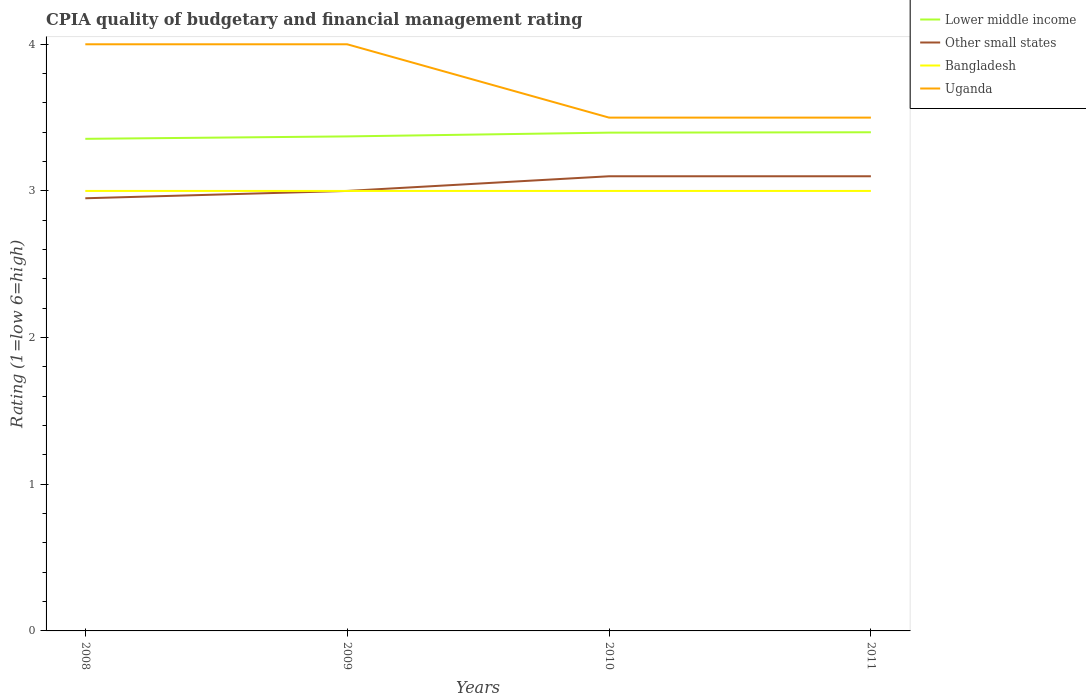How many different coloured lines are there?
Offer a very short reply. 4. Across all years, what is the maximum CPIA rating in Lower middle income?
Provide a succinct answer. 3.36. What is the total CPIA rating in Lower middle income in the graph?
Keep it short and to the point. -0.02. What is the difference between the highest and the second highest CPIA rating in Bangladesh?
Provide a succinct answer. 0. What is the difference between the highest and the lowest CPIA rating in Bangladesh?
Offer a terse response. 0. Is the CPIA rating in Bangladesh strictly greater than the CPIA rating in Lower middle income over the years?
Make the answer very short. Yes. How many years are there in the graph?
Offer a very short reply. 4. What is the difference between two consecutive major ticks on the Y-axis?
Keep it short and to the point. 1. Does the graph contain any zero values?
Give a very brief answer. No. How are the legend labels stacked?
Provide a short and direct response. Vertical. What is the title of the graph?
Provide a short and direct response. CPIA quality of budgetary and financial management rating. Does "Egypt, Arab Rep." appear as one of the legend labels in the graph?
Offer a very short reply. No. What is the label or title of the Y-axis?
Your answer should be very brief. Rating (1=low 6=high). What is the Rating (1=low 6=high) in Lower middle income in 2008?
Your answer should be very brief. 3.36. What is the Rating (1=low 6=high) of Other small states in 2008?
Your answer should be compact. 2.95. What is the Rating (1=low 6=high) in Uganda in 2008?
Ensure brevity in your answer.  4. What is the Rating (1=low 6=high) of Lower middle income in 2009?
Provide a short and direct response. 3.37. What is the Rating (1=low 6=high) in Bangladesh in 2009?
Your answer should be very brief. 3. What is the Rating (1=low 6=high) of Lower middle income in 2010?
Your answer should be compact. 3.4. What is the Rating (1=low 6=high) of Bangladesh in 2011?
Give a very brief answer. 3. Across all years, what is the maximum Rating (1=low 6=high) of Lower middle income?
Offer a terse response. 3.4. Across all years, what is the minimum Rating (1=low 6=high) in Lower middle income?
Provide a short and direct response. 3.36. Across all years, what is the minimum Rating (1=low 6=high) in Other small states?
Make the answer very short. 2.95. Across all years, what is the minimum Rating (1=low 6=high) in Bangladesh?
Your answer should be compact. 3. What is the total Rating (1=low 6=high) of Lower middle income in the graph?
Make the answer very short. 13.52. What is the total Rating (1=low 6=high) of Other small states in the graph?
Your answer should be compact. 12.15. What is the total Rating (1=low 6=high) of Bangladesh in the graph?
Your response must be concise. 12. What is the total Rating (1=low 6=high) of Uganda in the graph?
Keep it short and to the point. 15. What is the difference between the Rating (1=low 6=high) of Lower middle income in 2008 and that in 2009?
Provide a succinct answer. -0.02. What is the difference between the Rating (1=low 6=high) of Other small states in 2008 and that in 2009?
Your response must be concise. -0.05. What is the difference between the Rating (1=low 6=high) in Lower middle income in 2008 and that in 2010?
Provide a succinct answer. -0.04. What is the difference between the Rating (1=low 6=high) of Other small states in 2008 and that in 2010?
Your answer should be compact. -0.15. What is the difference between the Rating (1=low 6=high) of Lower middle income in 2008 and that in 2011?
Provide a short and direct response. -0.04. What is the difference between the Rating (1=low 6=high) in Other small states in 2008 and that in 2011?
Provide a short and direct response. -0.15. What is the difference between the Rating (1=low 6=high) in Bangladesh in 2008 and that in 2011?
Your response must be concise. 0. What is the difference between the Rating (1=low 6=high) in Lower middle income in 2009 and that in 2010?
Your answer should be compact. -0.03. What is the difference between the Rating (1=low 6=high) in Other small states in 2009 and that in 2010?
Provide a succinct answer. -0.1. What is the difference between the Rating (1=low 6=high) in Bangladesh in 2009 and that in 2010?
Keep it short and to the point. 0. What is the difference between the Rating (1=low 6=high) in Lower middle income in 2009 and that in 2011?
Give a very brief answer. -0.03. What is the difference between the Rating (1=low 6=high) in Bangladesh in 2009 and that in 2011?
Give a very brief answer. 0. What is the difference between the Rating (1=low 6=high) of Lower middle income in 2010 and that in 2011?
Your answer should be very brief. -0. What is the difference between the Rating (1=low 6=high) of Other small states in 2010 and that in 2011?
Offer a very short reply. 0. What is the difference between the Rating (1=low 6=high) of Bangladesh in 2010 and that in 2011?
Make the answer very short. 0. What is the difference between the Rating (1=low 6=high) of Lower middle income in 2008 and the Rating (1=low 6=high) of Other small states in 2009?
Provide a short and direct response. 0.36. What is the difference between the Rating (1=low 6=high) in Lower middle income in 2008 and the Rating (1=low 6=high) in Bangladesh in 2009?
Give a very brief answer. 0.36. What is the difference between the Rating (1=low 6=high) of Lower middle income in 2008 and the Rating (1=low 6=high) of Uganda in 2009?
Make the answer very short. -0.64. What is the difference between the Rating (1=low 6=high) of Other small states in 2008 and the Rating (1=low 6=high) of Uganda in 2009?
Your answer should be compact. -1.05. What is the difference between the Rating (1=low 6=high) of Bangladesh in 2008 and the Rating (1=low 6=high) of Uganda in 2009?
Offer a terse response. -1. What is the difference between the Rating (1=low 6=high) of Lower middle income in 2008 and the Rating (1=low 6=high) of Other small states in 2010?
Offer a very short reply. 0.26. What is the difference between the Rating (1=low 6=high) in Lower middle income in 2008 and the Rating (1=low 6=high) in Bangladesh in 2010?
Give a very brief answer. 0.36. What is the difference between the Rating (1=low 6=high) of Lower middle income in 2008 and the Rating (1=low 6=high) of Uganda in 2010?
Keep it short and to the point. -0.14. What is the difference between the Rating (1=low 6=high) of Other small states in 2008 and the Rating (1=low 6=high) of Bangladesh in 2010?
Give a very brief answer. -0.05. What is the difference between the Rating (1=low 6=high) of Other small states in 2008 and the Rating (1=low 6=high) of Uganda in 2010?
Offer a terse response. -0.55. What is the difference between the Rating (1=low 6=high) of Bangladesh in 2008 and the Rating (1=low 6=high) of Uganda in 2010?
Give a very brief answer. -0.5. What is the difference between the Rating (1=low 6=high) in Lower middle income in 2008 and the Rating (1=low 6=high) in Other small states in 2011?
Keep it short and to the point. 0.26. What is the difference between the Rating (1=low 6=high) of Lower middle income in 2008 and the Rating (1=low 6=high) of Bangladesh in 2011?
Your answer should be compact. 0.36. What is the difference between the Rating (1=low 6=high) in Lower middle income in 2008 and the Rating (1=low 6=high) in Uganda in 2011?
Offer a terse response. -0.14. What is the difference between the Rating (1=low 6=high) of Other small states in 2008 and the Rating (1=low 6=high) of Uganda in 2011?
Provide a short and direct response. -0.55. What is the difference between the Rating (1=low 6=high) of Lower middle income in 2009 and the Rating (1=low 6=high) of Other small states in 2010?
Ensure brevity in your answer.  0.27. What is the difference between the Rating (1=low 6=high) of Lower middle income in 2009 and the Rating (1=low 6=high) of Bangladesh in 2010?
Ensure brevity in your answer.  0.37. What is the difference between the Rating (1=low 6=high) in Lower middle income in 2009 and the Rating (1=low 6=high) in Uganda in 2010?
Give a very brief answer. -0.13. What is the difference between the Rating (1=low 6=high) in Bangladesh in 2009 and the Rating (1=low 6=high) in Uganda in 2010?
Your answer should be very brief. -0.5. What is the difference between the Rating (1=low 6=high) in Lower middle income in 2009 and the Rating (1=low 6=high) in Other small states in 2011?
Your answer should be compact. 0.27. What is the difference between the Rating (1=low 6=high) in Lower middle income in 2009 and the Rating (1=low 6=high) in Bangladesh in 2011?
Offer a terse response. 0.37. What is the difference between the Rating (1=low 6=high) in Lower middle income in 2009 and the Rating (1=low 6=high) in Uganda in 2011?
Give a very brief answer. -0.13. What is the difference between the Rating (1=low 6=high) of Other small states in 2009 and the Rating (1=low 6=high) of Bangladesh in 2011?
Give a very brief answer. 0. What is the difference between the Rating (1=low 6=high) in Other small states in 2009 and the Rating (1=low 6=high) in Uganda in 2011?
Your response must be concise. -0.5. What is the difference between the Rating (1=low 6=high) of Bangladesh in 2009 and the Rating (1=low 6=high) of Uganda in 2011?
Keep it short and to the point. -0.5. What is the difference between the Rating (1=low 6=high) in Lower middle income in 2010 and the Rating (1=low 6=high) in Other small states in 2011?
Your answer should be very brief. 0.3. What is the difference between the Rating (1=low 6=high) of Lower middle income in 2010 and the Rating (1=low 6=high) of Bangladesh in 2011?
Provide a succinct answer. 0.4. What is the difference between the Rating (1=low 6=high) in Lower middle income in 2010 and the Rating (1=low 6=high) in Uganda in 2011?
Ensure brevity in your answer.  -0.1. What is the difference between the Rating (1=low 6=high) of Other small states in 2010 and the Rating (1=low 6=high) of Uganda in 2011?
Your response must be concise. -0.4. What is the difference between the Rating (1=low 6=high) of Bangladesh in 2010 and the Rating (1=low 6=high) of Uganda in 2011?
Offer a very short reply. -0.5. What is the average Rating (1=low 6=high) of Lower middle income per year?
Offer a terse response. 3.38. What is the average Rating (1=low 6=high) of Other small states per year?
Offer a terse response. 3.04. What is the average Rating (1=low 6=high) of Bangladesh per year?
Offer a very short reply. 3. What is the average Rating (1=low 6=high) in Uganda per year?
Keep it short and to the point. 3.75. In the year 2008, what is the difference between the Rating (1=low 6=high) of Lower middle income and Rating (1=low 6=high) of Other small states?
Your answer should be compact. 0.41. In the year 2008, what is the difference between the Rating (1=low 6=high) of Lower middle income and Rating (1=low 6=high) of Bangladesh?
Your answer should be very brief. 0.36. In the year 2008, what is the difference between the Rating (1=low 6=high) of Lower middle income and Rating (1=low 6=high) of Uganda?
Provide a short and direct response. -0.64. In the year 2008, what is the difference between the Rating (1=low 6=high) of Other small states and Rating (1=low 6=high) of Uganda?
Offer a very short reply. -1.05. In the year 2008, what is the difference between the Rating (1=low 6=high) of Bangladesh and Rating (1=low 6=high) of Uganda?
Give a very brief answer. -1. In the year 2009, what is the difference between the Rating (1=low 6=high) of Lower middle income and Rating (1=low 6=high) of Other small states?
Ensure brevity in your answer.  0.37. In the year 2009, what is the difference between the Rating (1=low 6=high) in Lower middle income and Rating (1=low 6=high) in Bangladesh?
Your answer should be compact. 0.37. In the year 2009, what is the difference between the Rating (1=low 6=high) in Lower middle income and Rating (1=low 6=high) in Uganda?
Offer a terse response. -0.63. In the year 2009, what is the difference between the Rating (1=low 6=high) of Other small states and Rating (1=low 6=high) of Bangladesh?
Offer a very short reply. 0. In the year 2010, what is the difference between the Rating (1=low 6=high) in Lower middle income and Rating (1=low 6=high) in Other small states?
Offer a very short reply. 0.3. In the year 2010, what is the difference between the Rating (1=low 6=high) of Lower middle income and Rating (1=low 6=high) of Bangladesh?
Make the answer very short. 0.4. In the year 2010, what is the difference between the Rating (1=low 6=high) in Lower middle income and Rating (1=low 6=high) in Uganda?
Ensure brevity in your answer.  -0.1. In the year 2010, what is the difference between the Rating (1=low 6=high) in Other small states and Rating (1=low 6=high) in Bangladesh?
Provide a succinct answer. 0.1. In the year 2011, what is the difference between the Rating (1=low 6=high) of Lower middle income and Rating (1=low 6=high) of Uganda?
Offer a terse response. -0.1. In the year 2011, what is the difference between the Rating (1=low 6=high) in Other small states and Rating (1=low 6=high) in Bangladesh?
Your answer should be compact. 0.1. In the year 2011, what is the difference between the Rating (1=low 6=high) of Other small states and Rating (1=low 6=high) of Uganda?
Give a very brief answer. -0.4. What is the ratio of the Rating (1=low 6=high) in Lower middle income in 2008 to that in 2009?
Offer a very short reply. 1. What is the ratio of the Rating (1=low 6=high) of Other small states in 2008 to that in 2009?
Your answer should be compact. 0.98. What is the ratio of the Rating (1=low 6=high) in Bangladesh in 2008 to that in 2009?
Ensure brevity in your answer.  1. What is the ratio of the Rating (1=low 6=high) in Uganda in 2008 to that in 2009?
Give a very brief answer. 1. What is the ratio of the Rating (1=low 6=high) of Lower middle income in 2008 to that in 2010?
Make the answer very short. 0.99. What is the ratio of the Rating (1=low 6=high) of Other small states in 2008 to that in 2010?
Offer a terse response. 0.95. What is the ratio of the Rating (1=low 6=high) in Bangladesh in 2008 to that in 2010?
Provide a succinct answer. 1. What is the ratio of the Rating (1=low 6=high) of Uganda in 2008 to that in 2010?
Give a very brief answer. 1.14. What is the ratio of the Rating (1=low 6=high) in Other small states in 2008 to that in 2011?
Offer a very short reply. 0.95. What is the ratio of the Rating (1=low 6=high) in Uganda in 2009 to that in 2010?
Provide a succinct answer. 1.14. What is the ratio of the Rating (1=low 6=high) of Lower middle income in 2009 to that in 2011?
Provide a short and direct response. 0.99. What is the ratio of the Rating (1=low 6=high) in Bangladesh in 2009 to that in 2011?
Your answer should be compact. 1. What is the ratio of the Rating (1=low 6=high) of Uganda in 2009 to that in 2011?
Make the answer very short. 1.14. What is the ratio of the Rating (1=low 6=high) in Bangladesh in 2010 to that in 2011?
Offer a terse response. 1. What is the ratio of the Rating (1=low 6=high) in Uganda in 2010 to that in 2011?
Your response must be concise. 1. What is the difference between the highest and the second highest Rating (1=low 6=high) in Lower middle income?
Your answer should be very brief. 0. What is the difference between the highest and the second highest Rating (1=low 6=high) in Other small states?
Your response must be concise. 0. What is the difference between the highest and the second highest Rating (1=low 6=high) in Bangladesh?
Offer a terse response. 0. What is the difference between the highest and the lowest Rating (1=low 6=high) in Lower middle income?
Give a very brief answer. 0.04. What is the difference between the highest and the lowest Rating (1=low 6=high) in Uganda?
Your response must be concise. 0.5. 